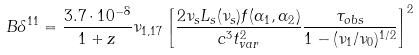Convert formula to latex. <formula><loc_0><loc_0><loc_500><loc_500>B \delta ^ { 1 1 } = \frac { 3 . 7 \cdot 1 0 ^ { - 8 } } { 1 + z } \nu _ { 1 , 1 7 } \left [ \frac { 2 \nu _ { s } L _ { s } ( \nu _ { s } ) f ( \alpha _ { 1 } , \alpha _ { 2 } ) } { c ^ { 3 } t _ { v a r } ^ { 2 } } \frac { \tau _ { o b s } } { 1 - ( \nu _ { 1 } / \nu _ { 0 } ) ^ { 1 / 2 } } \right ] ^ { 2 }</formula> 